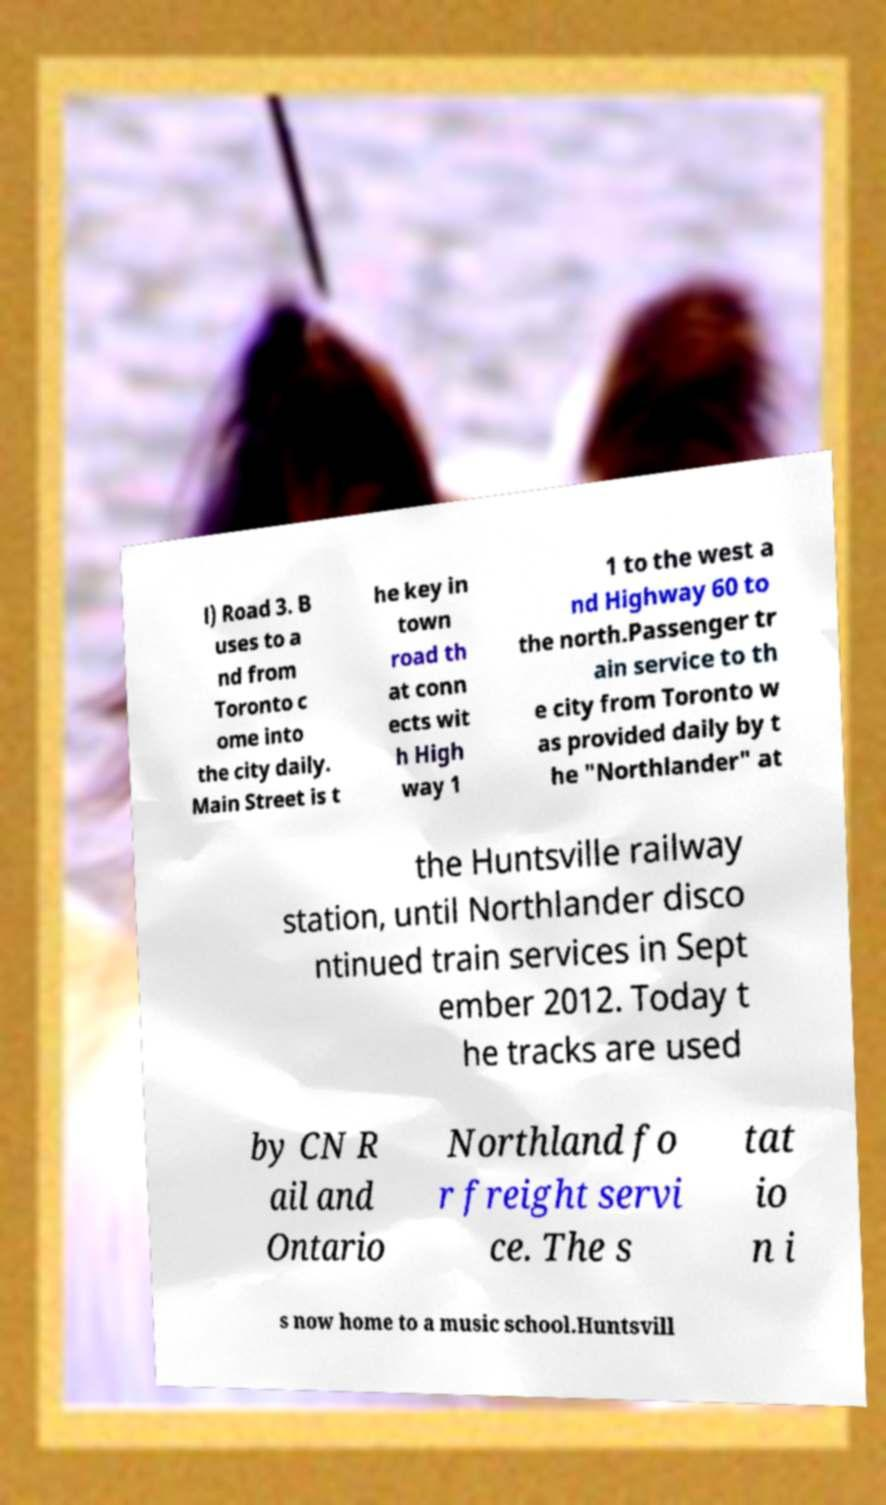Please read and relay the text visible in this image. What does it say? l) Road 3. B uses to a nd from Toronto c ome into the city daily. Main Street is t he key in town road th at conn ects wit h High way 1 1 to the west a nd Highway 60 to the north.Passenger tr ain service to th e city from Toronto w as provided daily by t he "Northlander" at the Huntsville railway station, until Northlander disco ntinued train services in Sept ember 2012. Today t he tracks are used by CN R ail and Ontario Northland fo r freight servi ce. The s tat io n i s now home to a music school.Huntsvill 